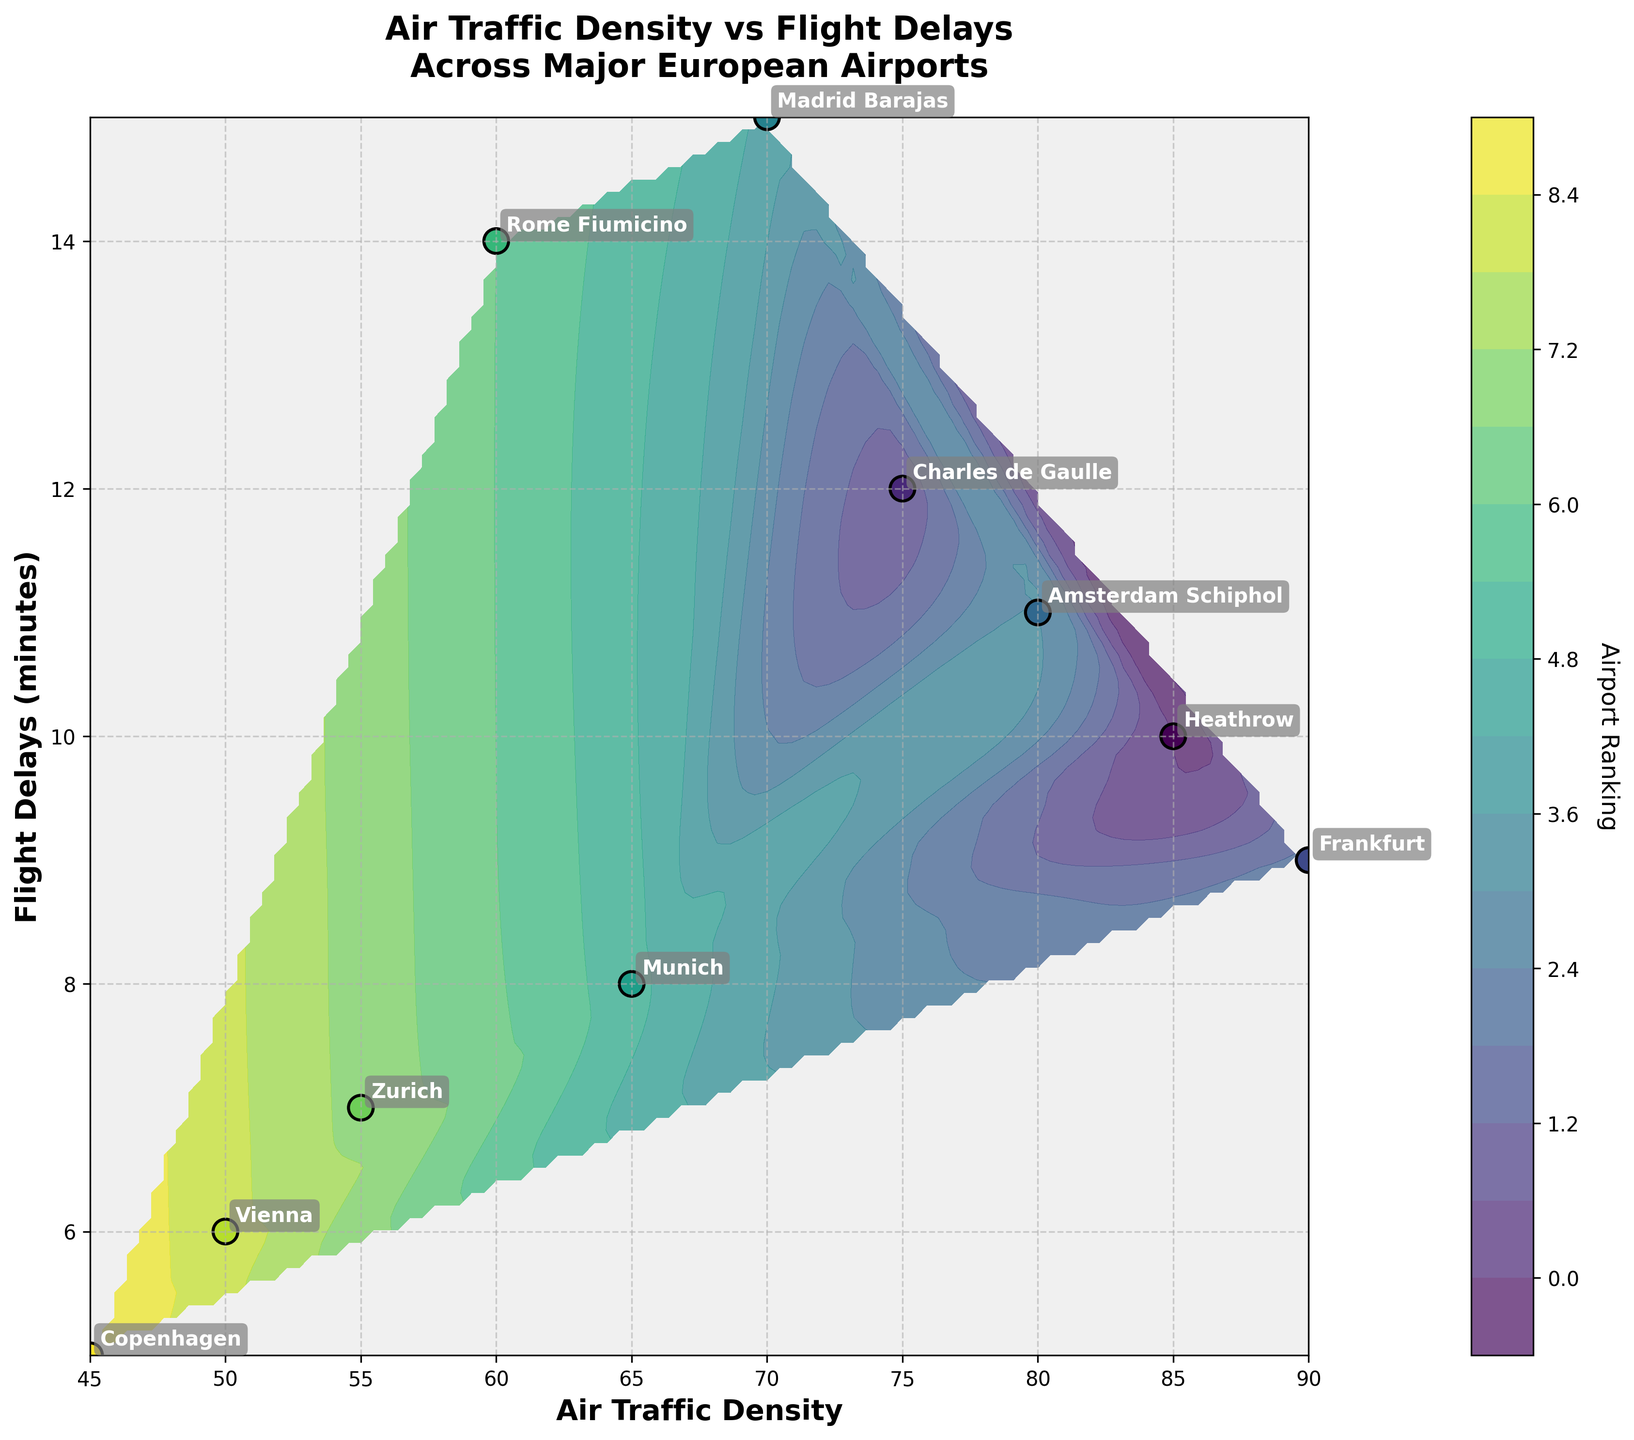What is the title of the plot? The title is located at the top of the figure. By reading the text at the top-center of the plot, we can identify the title.
Answer: Air Traffic Density vs Flight Delays Across Major European Airports What is the color used to fill the data points in the plot? The scatter points in the plot are colored using a gradient from a colormap, which is typically visible in the contour plot. By looking carefully at the scatter points, we can identify the colors as they transition from lighter to darker shades.
Answer: Various shades of green to blue (viridis colormap) Which airport has the highest air traffic density? By observing the x-axis, which represents air traffic density, and identifying the maximum value among the data points, we can determine the airport with the highest air traffic density.
Answer: Frankfurt (90) Which airports have a higher flight delay than Zurich? We start by finding the flight delay for Zurich on the y-axis, which is 7 minutes. Then, we look for all data points above this value on the y-axis.
Answer: Heathrow (10), Charles de Gaulle (12), Amsterdam Schiphol (11), Madrid Barajas (15), Rome Fiumicino (14) What is the relationship between air traffic density and flight delays based on the plot? By analyzing the contour and scatter plots, we observe the correlation pattern between the x-axis (air traffic density) and y-axis (flight delays).
Answer: Generally, higher air traffic density correlates with slightly higher flight delays Identify the airport with the least flight delays and its air traffic density. By scanning the y-axis to find the minimum flight delay, we can locate the corresponding data point and read the air traffic density from the x-axis.
Answer: Copenhagen (45 traffic density, 5 flight delays) Which airport pair shows the highest difference in flight delays, and what is that difference? By comparing the y-axis values of all airports, we identify the maximum and minimum flight delays and calculate the difference.
Answer: Madrid Barajas (15) and Copenhagen (5), the difference is 10 minutes Rank the airports based on their air traffic density from highest to lowest. We list down the x-values for all data points (air traffic density) and sort them in descending order, then read the corresponding airport names.
Answer: Frankfurt, Heathrow, Amsterdam Schiphol, Charles de Gaulle, Madrid Barajas, Munich, Rome Fiumicino, Zurich, Vienna, Copenhagen Considering flight delays, what is the difference between Amsterdam Schiphol and Munich? Next, identify the y-values (flight delays) for both airports and subtract one from the other to get the difference.
Answer: 11 - 8 = 3 minutes Which airport has both below-average air traffic density and flight delays? Calculate the average air traffic density and flight delays. Then, find the airport with both metrics below these average values.
Answer: The average air traffic density is 67.5 and average flight delays is 10. Zurich (55, 7) and Vienna (50, 6) 